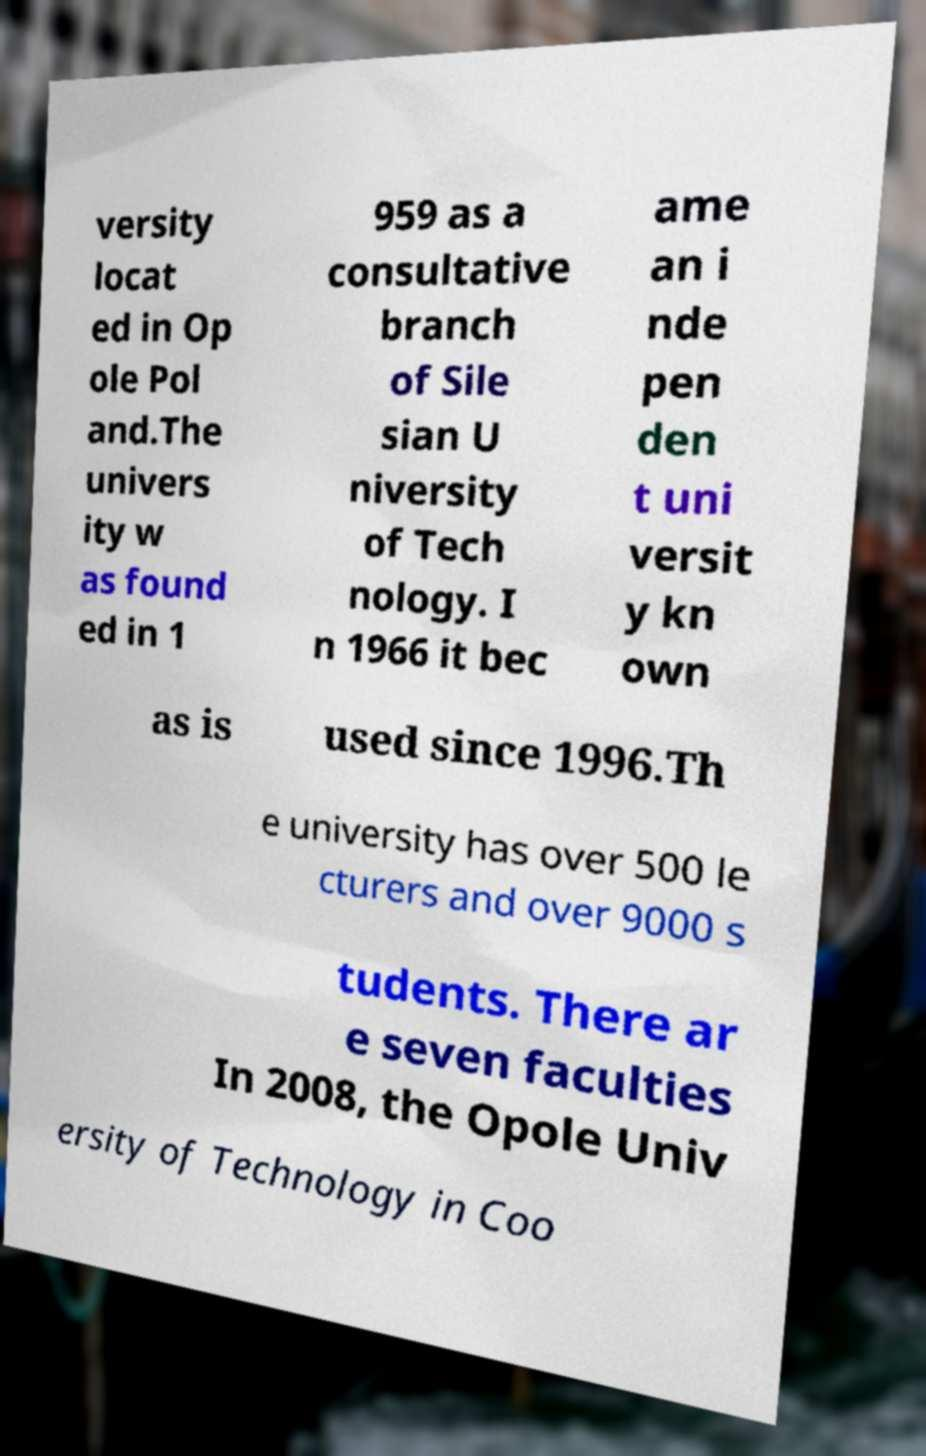Can you read and provide the text displayed in the image?This photo seems to have some interesting text. Can you extract and type it out for me? versity locat ed in Op ole Pol and.The univers ity w as found ed in 1 959 as a consultative branch of Sile sian U niversity of Tech nology. I n 1966 it bec ame an i nde pen den t uni versit y kn own as is used since 1996.Th e university has over 500 le cturers and over 9000 s tudents. There ar e seven faculties In 2008, the Opole Univ ersity of Technology in Coo 